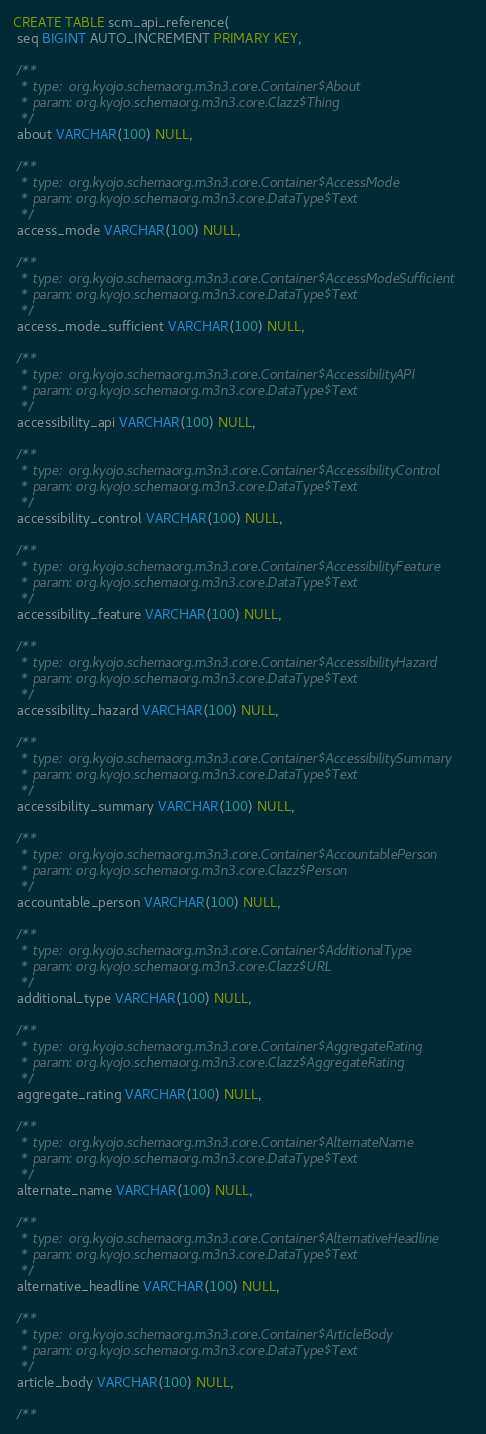Convert code to text. <code><loc_0><loc_0><loc_500><loc_500><_SQL_>CREATE TABLE scm_api_reference(
 seq BIGINT AUTO_INCREMENT PRIMARY KEY,

 /**
  * type:  org.kyojo.schemaorg.m3n3.core.Container$About
  * param: org.kyojo.schemaorg.m3n3.core.Clazz$Thing
  */
 about VARCHAR(100) NULL,

 /**
  * type:  org.kyojo.schemaorg.m3n3.core.Container$AccessMode
  * param: org.kyojo.schemaorg.m3n3.core.DataType$Text
  */
 access_mode VARCHAR(100) NULL,

 /**
  * type:  org.kyojo.schemaorg.m3n3.core.Container$AccessModeSufficient
  * param: org.kyojo.schemaorg.m3n3.core.DataType$Text
  */
 access_mode_sufficient VARCHAR(100) NULL,

 /**
  * type:  org.kyojo.schemaorg.m3n3.core.Container$AccessibilityAPI
  * param: org.kyojo.schemaorg.m3n3.core.DataType$Text
  */
 accessibility_api VARCHAR(100) NULL,

 /**
  * type:  org.kyojo.schemaorg.m3n3.core.Container$AccessibilityControl
  * param: org.kyojo.schemaorg.m3n3.core.DataType$Text
  */
 accessibility_control VARCHAR(100) NULL,

 /**
  * type:  org.kyojo.schemaorg.m3n3.core.Container$AccessibilityFeature
  * param: org.kyojo.schemaorg.m3n3.core.DataType$Text
  */
 accessibility_feature VARCHAR(100) NULL,

 /**
  * type:  org.kyojo.schemaorg.m3n3.core.Container$AccessibilityHazard
  * param: org.kyojo.schemaorg.m3n3.core.DataType$Text
  */
 accessibility_hazard VARCHAR(100) NULL,

 /**
  * type:  org.kyojo.schemaorg.m3n3.core.Container$AccessibilitySummary
  * param: org.kyojo.schemaorg.m3n3.core.DataType$Text
  */
 accessibility_summary VARCHAR(100) NULL,

 /**
  * type:  org.kyojo.schemaorg.m3n3.core.Container$AccountablePerson
  * param: org.kyojo.schemaorg.m3n3.core.Clazz$Person
  */
 accountable_person VARCHAR(100) NULL,

 /**
  * type:  org.kyojo.schemaorg.m3n3.core.Container$AdditionalType
  * param: org.kyojo.schemaorg.m3n3.core.Clazz$URL
  */
 additional_type VARCHAR(100) NULL,

 /**
  * type:  org.kyojo.schemaorg.m3n3.core.Container$AggregateRating
  * param: org.kyojo.schemaorg.m3n3.core.Clazz$AggregateRating
  */
 aggregate_rating VARCHAR(100) NULL,

 /**
  * type:  org.kyojo.schemaorg.m3n3.core.Container$AlternateName
  * param: org.kyojo.schemaorg.m3n3.core.DataType$Text
  */
 alternate_name VARCHAR(100) NULL,

 /**
  * type:  org.kyojo.schemaorg.m3n3.core.Container$AlternativeHeadline
  * param: org.kyojo.schemaorg.m3n3.core.DataType$Text
  */
 alternative_headline VARCHAR(100) NULL,

 /**
  * type:  org.kyojo.schemaorg.m3n3.core.Container$ArticleBody
  * param: org.kyojo.schemaorg.m3n3.core.DataType$Text
  */
 article_body VARCHAR(100) NULL,

 /**</code> 